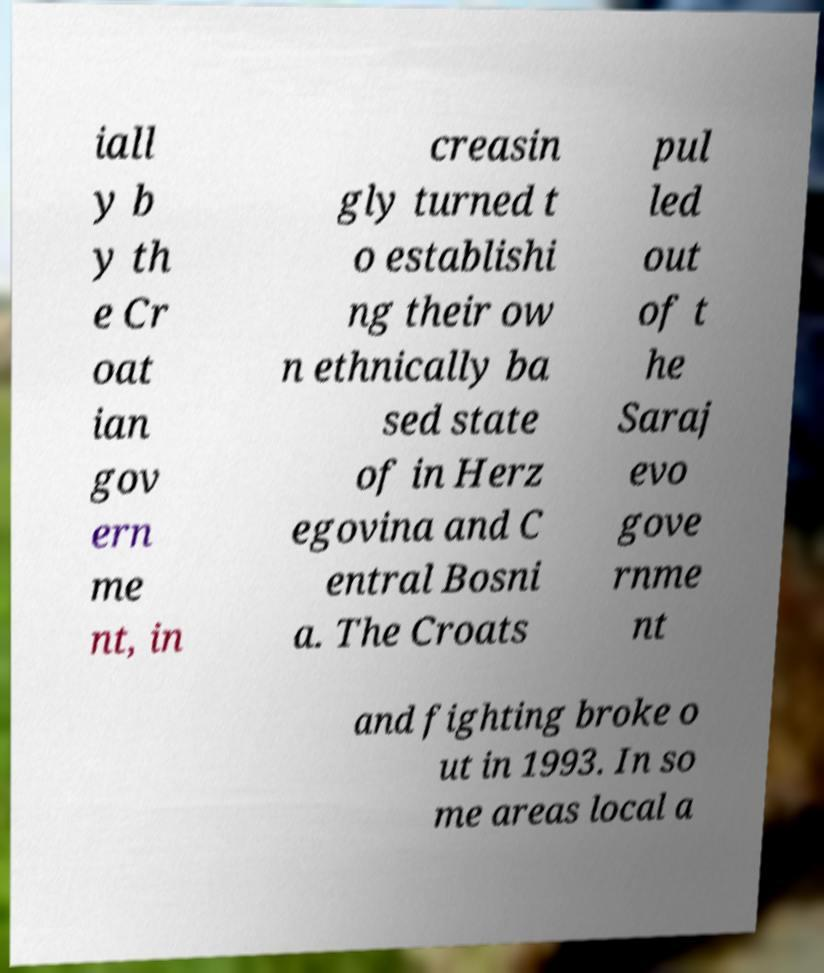There's text embedded in this image that I need extracted. Can you transcribe it verbatim? iall y b y th e Cr oat ian gov ern me nt, in creasin gly turned t o establishi ng their ow n ethnically ba sed state of in Herz egovina and C entral Bosni a. The Croats pul led out of t he Saraj evo gove rnme nt and fighting broke o ut in 1993. In so me areas local a 